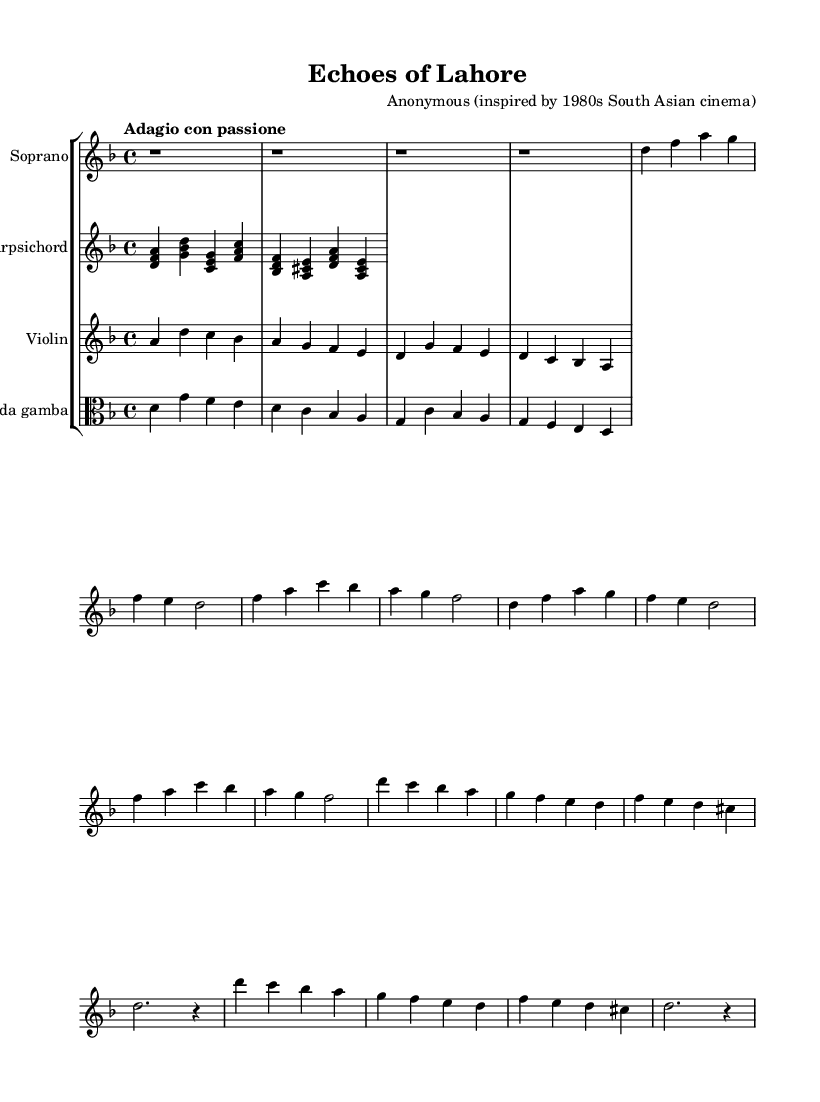What is the key signature of this music? The key signature is D minor, indicated by the two flats (B♭ and E♭) on the staff. The key signature is placed at the beginning of the staff, confirming the tonality of the piece.
Answer: D minor What is the time signature of this piece? The time signature is 4/4, which is indicated by the two numbers at the beginning of the piece. The upper number (4) signifies four beats per measure, while the lower number (4) indicates that a quarter note receives one beat.
Answer: 4/4 What is the tempo marking given in the music? The tempo marking is "Adagio con passione," which describes the speed (slow) and emotional intensity (with passion) of the performance. This marking is provided at the start of the piece to guide the musicians on how to interpret the music.
Answer: Adagio con passione How many instruments are indicated in the score? There are four instruments indicated in the score: soprano, harpsichord, violin, and viola da gamba. This can be deduced from the staff groupings presented in the score. Each instrument has its own designated staff or staves.
Answer: Four What are the main musical sections present in the arias? The main musical sections present are the "Introduction," "Verse," and "Chorus." These sections are typically indicated in the sheet music with corresponding musical phrases, allowing performers to navigate the structure easily.
Answer: Introduction, Verse, Chorus In which musical era is this piece classified? This piece is classified in the Baroque era, often characterized by its ornate style and emotional expressiveness. The musical elements such as the format of arias and the instrumental arrangements provide clear indicators of its Baroque classification.
Answer: Baroque 